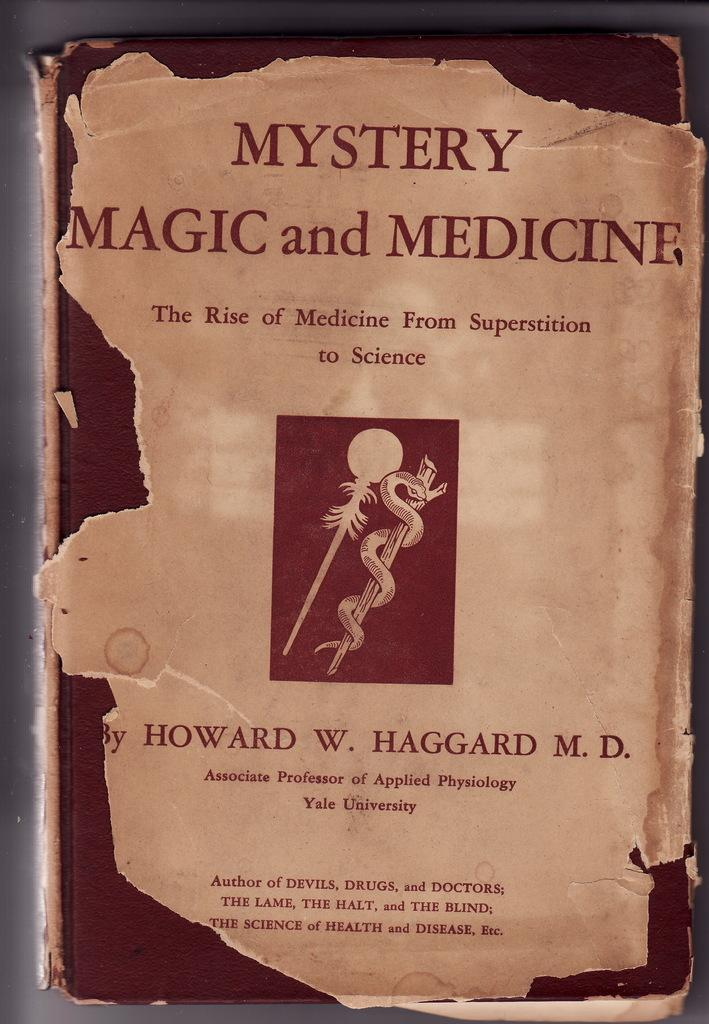<image>
Offer a succinct explanation of the picture presented. The book Mystery Magic and Medicine was written by Howard W. Haggard, who is a doctor. 